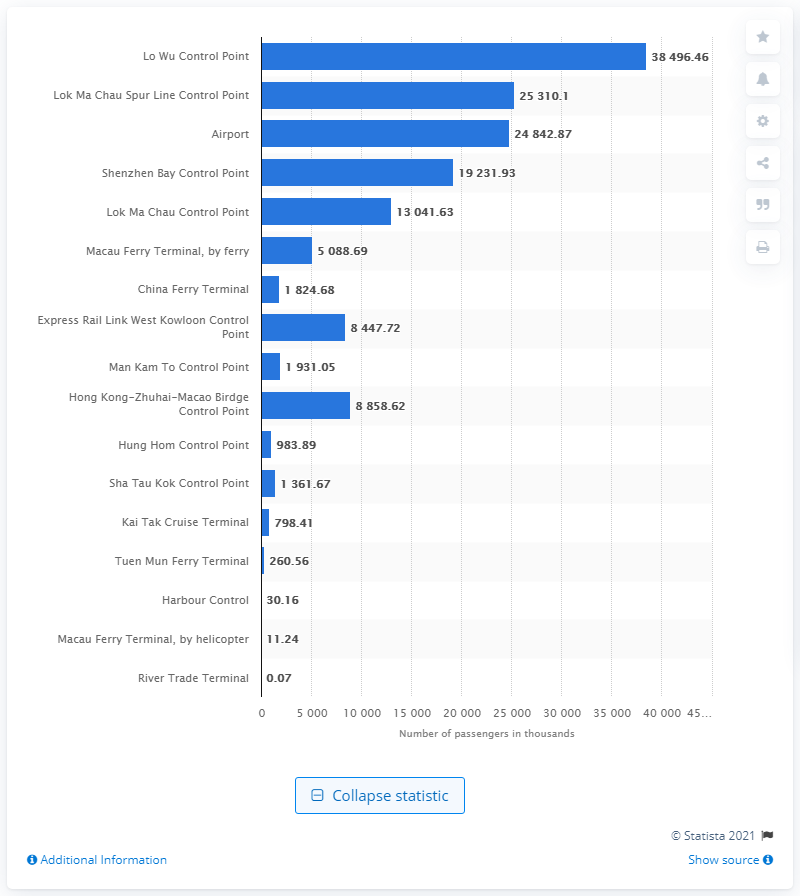List a handful of essential elements in this visual. According to a report released in 2019, Lo Wu Control Point was the busiest control point in Hong Kong. In 2019, the River Trade Terminal in Hong Kong transported a total of 67 passengers. 